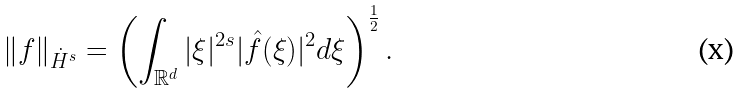Convert formula to latex. <formula><loc_0><loc_0><loc_500><loc_500>\| f \| _ { \dot { H } ^ { s } } = \left ( \int _ { \mathbb { R } ^ { d } } | \xi | ^ { 2 s } | \hat { f } ( \xi ) | ^ { 2 } d \xi \right ) ^ { \frac { 1 } { 2 } } .</formula> 